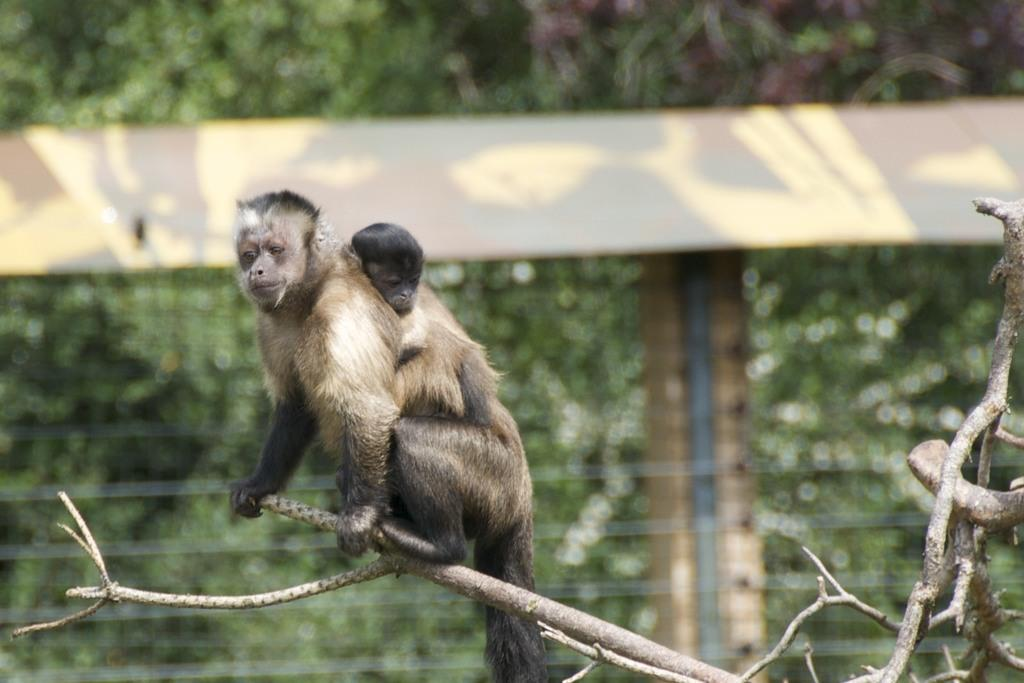What animal is the main subject of the image? There is a monkey in the image. Does the monkey have any offspring in the image? Yes, the monkey has a baby in the image. Where are the monkey and its baby located in the image? The monkey and its baby are sitting on a branch of a tree. How many rabbits can be seen hiding in the cave in the image? There are no rabbits or caves present in the image; it features a monkey and its baby on a tree branch. 